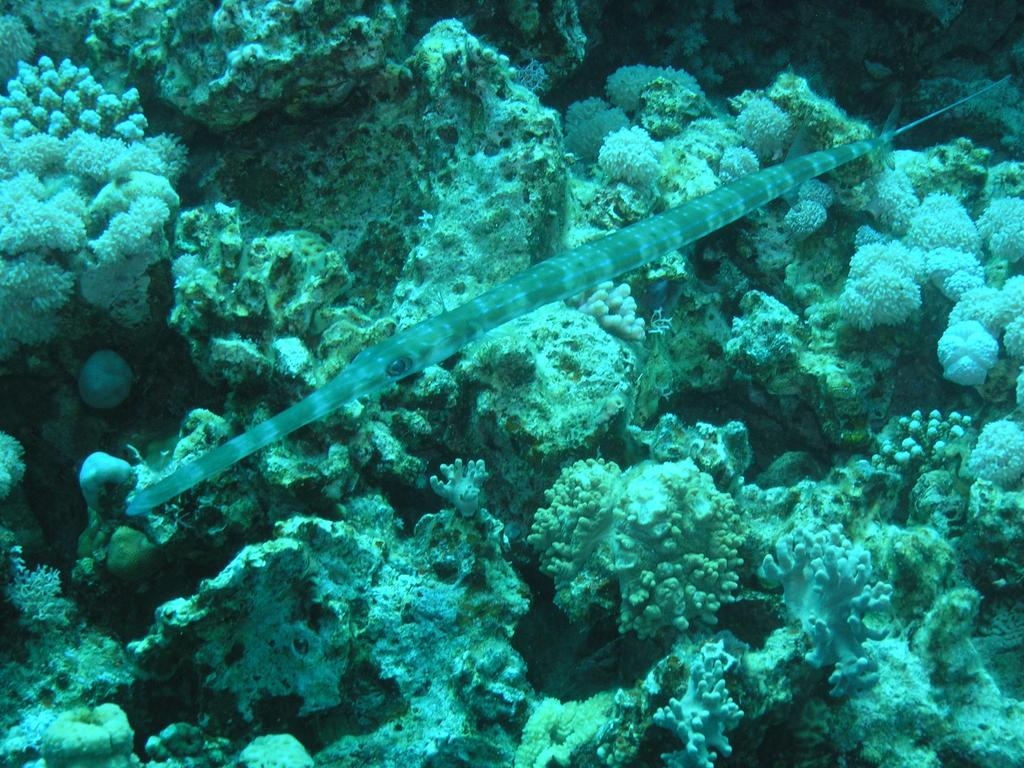What type of animal can be seen in the image? There is a sea animal in the image. What advice does the breakfast expert give about the earthquake in the image? There is no breakfast expert or earthquake present in the image; it only features a sea animal. 